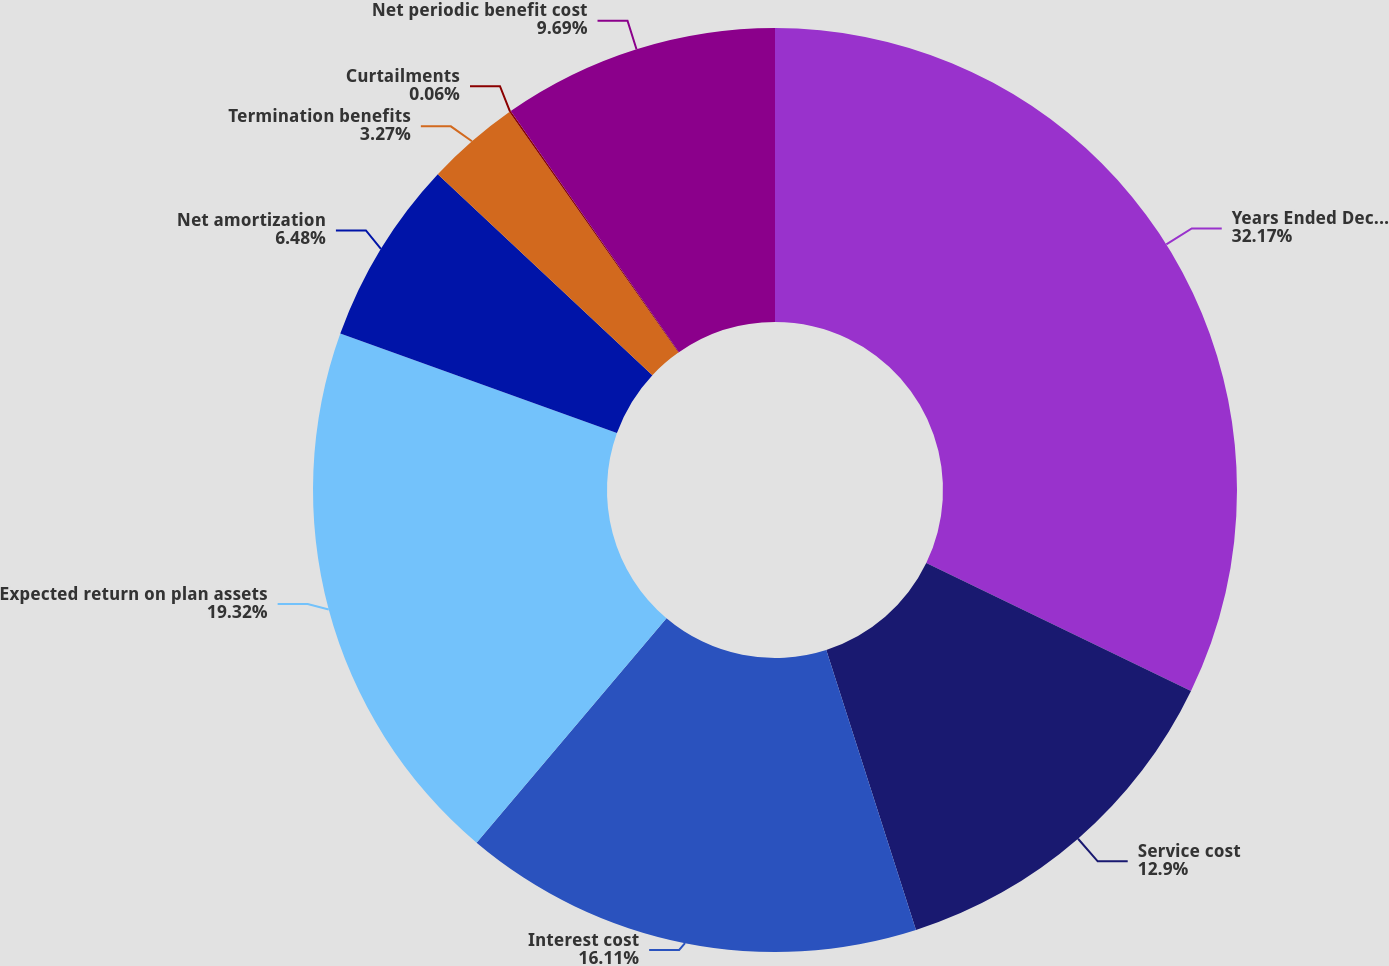<chart> <loc_0><loc_0><loc_500><loc_500><pie_chart><fcel>Years Ended December 31<fcel>Service cost<fcel>Interest cost<fcel>Expected return on plan assets<fcel>Net amortization<fcel>Termination benefits<fcel>Curtailments<fcel>Net periodic benefit cost<nl><fcel>32.16%<fcel>12.9%<fcel>16.11%<fcel>19.32%<fcel>6.48%<fcel>3.27%<fcel>0.06%<fcel>9.69%<nl></chart> 